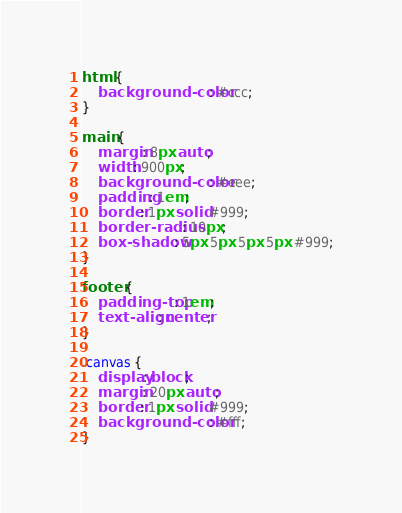Convert code to text. <code><loc_0><loc_0><loc_500><loc_500><_CSS_>html {
    background-color: #ccc;
}

main {
    margin: 8px auto;
    width: 900px;
    background-color: #eee;
    padding: 1em;
    border: 1px solid #999;
    border-radius: 10px;
    box-shadow: 5px 5px 5px 5px #999;
}

footer {
    padding-top: 1em;
    text-align: center;
}

.canvas {
    display: block;
    margin: 20px auto;
    border: 1px solid #999;
    background-color: #fff;
}
</code> 